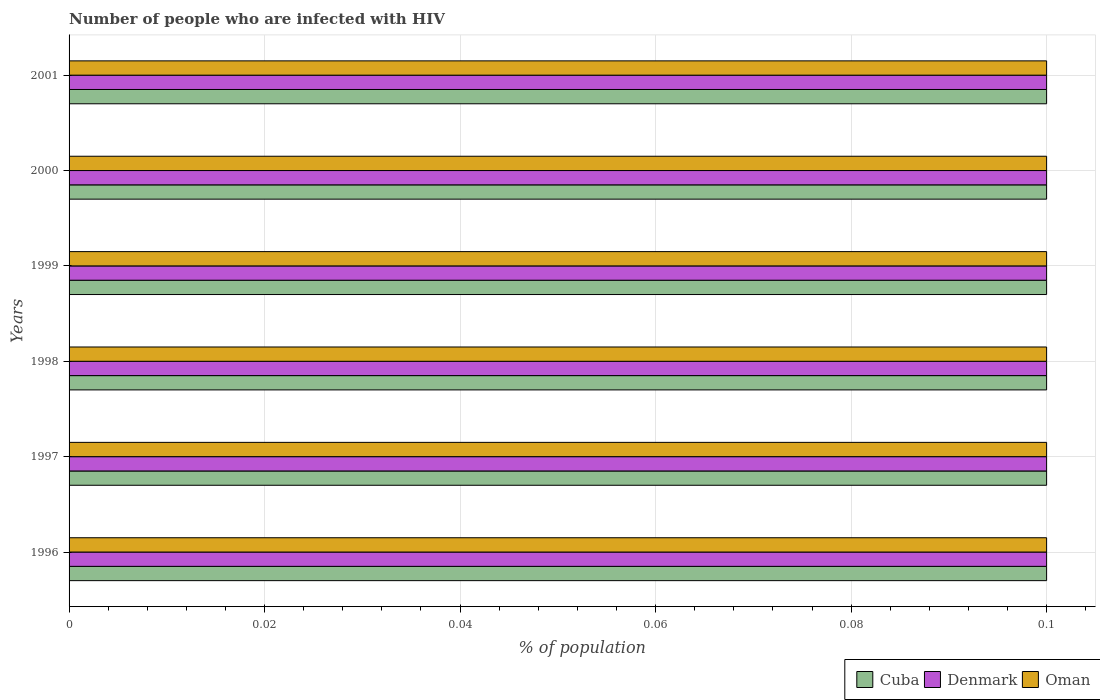How many different coloured bars are there?
Make the answer very short. 3. How many bars are there on the 1st tick from the top?
Ensure brevity in your answer.  3. How many bars are there on the 1st tick from the bottom?
Your answer should be very brief. 3. What is the label of the 2nd group of bars from the top?
Ensure brevity in your answer.  2000. What is the percentage of HIV infected population in in Denmark in 1996?
Make the answer very short. 0.1. Across all years, what is the maximum percentage of HIV infected population in in Oman?
Offer a terse response. 0.1. Across all years, what is the minimum percentage of HIV infected population in in Denmark?
Give a very brief answer. 0.1. In which year was the percentage of HIV infected population in in Oman maximum?
Your response must be concise. 1996. What is the difference between the percentage of HIV infected population in in Cuba in 1999 and that in 2001?
Keep it short and to the point. 0. What is the average percentage of HIV infected population in in Cuba per year?
Your answer should be very brief. 0.1. In how many years, is the percentage of HIV infected population in in Cuba greater than 0.016 %?
Your answer should be very brief. 6. What is the ratio of the percentage of HIV infected population in in Oman in 1999 to that in 2001?
Ensure brevity in your answer.  1. What is the difference between the highest and the second highest percentage of HIV infected population in in Denmark?
Keep it short and to the point. 0. What is the difference between the highest and the lowest percentage of HIV infected population in in Oman?
Offer a very short reply. 0. Is the sum of the percentage of HIV infected population in in Oman in 1997 and 2000 greater than the maximum percentage of HIV infected population in in Cuba across all years?
Provide a short and direct response. Yes. Is it the case that in every year, the sum of the percentage of HIV infected population in in Denmark and percentage of HIV infected population in in Cuba is greater than the percentage of HIV infected population in in Oman?
Make the answer very short. Yes. How many bars are there?
Provide a short and direct response. 18. How many years are there in the graph?
Your response must be concise. 6. Are the values on the major ticks of X-axis written in scientific E-notation?
Provide a succinct answer. No. Does the graph contain any zero values?
Your response must be concise. No. Does the graph contain grids?
Your answer should be compact. Yes. Where does the legend appear in the graph?
Provide a short and direct response. Bottom right. What is the title of the graph?
Make the answer very short. Number of people who are infected with HIV. What is the label or title of the X-axis?
Offer a very short reply. % of population. What is the % of population in Denmark in 1996?
Your response must be concise. 0.1. What is the % of population in Oman in 1996?
Keep it short and to the point. 0.1. What is the % of population in Cuba in 1997?
Offer a terse response. 0.1. What is the % of population of Cuba in 1998?
Your answer should be very brief. 0.1. What is the % of population in Cuba in 2000?
Keep it short and to the point. 0.1. What is the % of population in Denmark in 2000?
Offer a very short reply. 0.1. What is the % of population of Cuba in 2001?
Make the answer very short. 0.1. What is the % of population in Oman in 2001?
Give a very brief answer. 0.1. Across all years, what is the maximum % of population of Cuba?
Offer a terse response. 0.1. Across all years, what is the maximum % of population of Denmark?
Your response must be concise. 0.1. Across all years, what is the minimum % of population of Cuba?
Keep it short and to the point. 0.1. What is the total % of population in Cuba in the graph?
Your answer should be compact. 0.6. What is the total % of population of Denmark in the graph?
Offer a very short reply. 0.6. What is the difference between the % of population in Cuba in 1996 and that in 1997?
Offer a terse response. 0. What is the difference between the % of population of Denmark in 1996 and that in 1997?
Your answer should be compact. 0. What is the difference between the % of population of Oman in 1996 and that in 1997?
Offer a very short reply. 0. What is the difference between the % of population in Denmark in 1996 and that in 1998?
Provide a succinct answer. 0. What is the difference between the % of population of Denmark in 1996 and that in 1999?
Provide a succinct answer. 0. What is the difference between the % of population in Cuba in 1996 and that in 2001?
Ensure brevity in your answer.  0. What is the difference between the % of population in Denmark in 1996 and that in 2001?
Offer a terse response. 0. What is the difference between the % of population of Oman in 1997 and that in 1998?
Provide a short and direct response. 0. What is the difference between the % of population in Denmark in 1997 and that in 2000?
Provide a short and direct response. 0. What is the difference between the % of population in Oman in 1997 and that in 2000?
Your answer should be compact. 0. What is the difference between the % of population of Cuba in 1997 and that in 2001?
Ensure brevity in your answer.  0. What is the difference between the % of population in Denmark in 1997 and that in 2001?
Your answer should be very brief. 0. What is the difference between the % of population in Oman in 1997 and that in 2001?
Your answer should be very brief. 0. What is the difference between the % of population in Oman in 1998 and that in 1999?
Offer a terse response. 0. What is the difference between the % of population of Cuba in 1998 and that in 2000?
Make the answer very short. 0. What is the difference between the % of population of Denmark in 1998 and that in 2000?
Keep it short and to the point. 0. What is the difference between the % of population in Oman in 1998 and that in 2000?
Offer a very short reply. 0. What is the difference between the % of population of Cuba in 1998 and that in 2001?
Your answer should be very brief. 0. What is the difference between the % of population in Denmark in 1998 and that in 2001?
Give a very brief answer. 0. What is the difference between the % of population of Oman in 1999 and that in 2000?
Keep it short and to the point. 0. What is the difference between the % of population of Denmark in 1999 and that in 2001?
Your answer should be very brief. 0. What is the difference between the % of population of Denmark in 2000 and that in 2001?
Provide a succinct answer. 0. What is the difference between the % of population in Oman in 2000 and that in 2001?
Offer a very short reply. 0. What is the difference between the % of population of Cuba in 1996 and the % of population of Denmark in 1997?
Your response must be concise. 0. What is the difference between the % of population of Cuba in 1996 and the % of population of Oman in 1997?
Keep it short and to the point. 0. What is the difference between the % of population in Cuba in 1996 and the % of population in Denmark in 1998?
Ensure brevity in your answer.  0. What is the difference between the % of population in Denmark in 1996 and the % of population in Oman in 1998?
Your answer should be compact. 0. What is the difference between the % of population of Cuba in 1996 and the % of population of Denmark in 1999?
Keep it short and to the point. 0. What is the difference between the % of population of Denmark in 1996 and the % of population of Oman in 1999?
Provide a succinct answer. 0. What is the difference between the % of population in Cuba in 1996 and the % of population in Oman in 2001?
Give a very brief answer. 0. What is the difference between the % of population of Denmark in 1997 and the % of population of Oman in 1998?
Make the answer very short. 0. What is the difference between the % of population of Cuba in 1997 and the % of population of Denmark in 1999?
Offer a very short reply. 0. What is the difference between the % of population of Cuba in 1997 and the % of population of Oman in 1999?
Offer a terse response. 0. What is the difference between the % of population of Denmark in 1997 and the % of population of Oman in 2000?
Ensure brevity in your answer.  0. What is the difference between the % of population of Denmark in 1997 and the % of population of Oman in 2001?
Your answer should be compact. 0. What is the difference between the % of population of Cuba in 1998 and the % of population of Oman in 1999?
Provide a short and direct response. 0. What is the difference between the % of population in Denmark in 1998 and the % of population in Oman in 1999?
Offer a terse response. 0. What is the difference between the % of population in Cuba in 1998 and the % of population in Oman in 2000?
Ensure brevity in your answer.  0. What is the difference between the % of population of Cuba in 1998 and the % of population of Oman in 2001?
Make the answer very short. 0. What is the difference between the % of population of Denmark in 1998 and the % of population of Oman in 2001?
Provide a short and direct response. 0. What is the difference between the % of population of Denmark in 2000 and the % of population of Oman in 2001?
Provide a short and direct response. 0. In the year 1996, what is the difference between the % of population in Cuba and % of population in Oman?
Keep it short and to the point. 0. In the year 1996, what is the difference between the % of population of Denmark and % of population of Oman?
Provide a short and direct response. 0. In the year 1997, what is the difference between the % of population of Cuba and % of population of Denmark?
Offer a very short reply. 0. In the year 1997, what is the difference between the % of population in Denmark and % of population in Oman?
Ensure brevity in your answer.  0. In the year 1998, what is the difference between the % of population of Cuba and % of population of Denmark?
Your answer should be very brief. 0. In the year 1998, what is the difference between the % of population in Cuba and % of population in Oman?
Your answer should be compact. 0. In the year 1998, what is the difference between the % of population of Denmark and % of population of Oman?
Make the answer very short. 0. In the year 1999, what is the difference between the % of population in Cuba and % of population in Denmark?
Your answer should be very brief. 0. In the year 1999, what is the difference between the % of population of Cuba and % of population of Oman?
Ensure brevity in your answer.  0. In the year 1999, what is the difference between the % of population in Denmark and % of population in Oman?
Offer a terse response. 0. In the year 2000, what is the difference between the % of population in Cuba and % of population in Oman?
Your response must be concise. 0. In the year 2000, what is the difference between the % of population in Denmark and % of population in Oman?
Offer a very short reply. 0. In the year 2001, what is the difference between the % of population of Cuba and % of population of Denmark?
Offer a very short reply. 0. In the year 2001, what is the difference between the % of population of Cuba and % of population of Oman?
Make the answer very short. 0. What is the ratio of the % of population in Cuba in 1996 to that in 1997?
Ensure brevity in your answer.  1. What is the ratio of the % of population of Denmark in 1996 to that in 1997?
Offer a very short reply. 1. What is the ratio of the % of population of Cuba in 1996 to that in 1998?
Provide a short and direct response. 1. What is the ratio of the % of population in Denmark in 1996 to that in 1998?
Make the answer very short. 1. What is the ratio of the % of population in Cuba in 1996 to that in 1999?
Your answer should be very brief. 1. What is the ratio of the % of population of Cuba in 1996 to that in 2000?
Your response must be concise. 1. What is the ratio of the % of population of Denmark in 1996 to that in 2000?
Your answer should be very brief. 1. What is the ratio of the % of population in Oman in 1996 to that in 2000?
Provide a short and direct response. 1. What is the ratio of the % of population in Denmark in 1997 to that in 1998?
Give a very brief answer. 1. What is the ratio of the % of population of Oman in 1997 to that in 1998?
Your response must be concise. 1. What is the ratio of the % of population of Cuba in 1997 to that in 1999?
Your answer should be compact. 1. What is the ratio of the % of population in Cuba in 1997 to that in 2001?
Provide a short and direct response. 1. What is the ratio of the % of population in Denmark in 1998 to that in 2000?
Keep it short and to the point. 1. What is the ratio of the % of population in Cuba in 1998 to that in 2001?
Offer a very short reply. 1. What is the ratio of the % of population in Cuba in 1999 to that in 2000?
Offer a terse response. 1. What is the ratio of the % of population of Denmark in 1999 to that in 2001?
Offer a very short reply. 1. What is the ratio of the % of population of Cuba in 2000 to that in 2001?
Make the answer very short. 1. What is the ratio of the % of population of Denmark in 2000 to that in 2001?
Provide a short and direct response. 1. What is the difference between the highest and the second highest % of population in Cuba?
Make the answer very short. 0. What is the difference between the highest and the second highest % of population of Denmark?
Offer a terse response. 0. What is the difference between the highest and the lowest % of population in Denmark?
Offer a very short reply. 0. What is the difference between the highest and the lowest % of population of Oman?
Give a very brief answer. 0. 